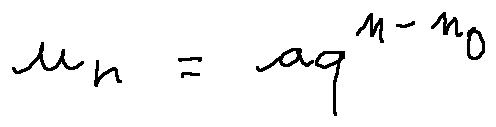Convert formula to latex. <formula><loc_0><loc_0><loc_500><loc_500>u _ { n } = a q ^ { n - n _ { 0 } }</formula> 